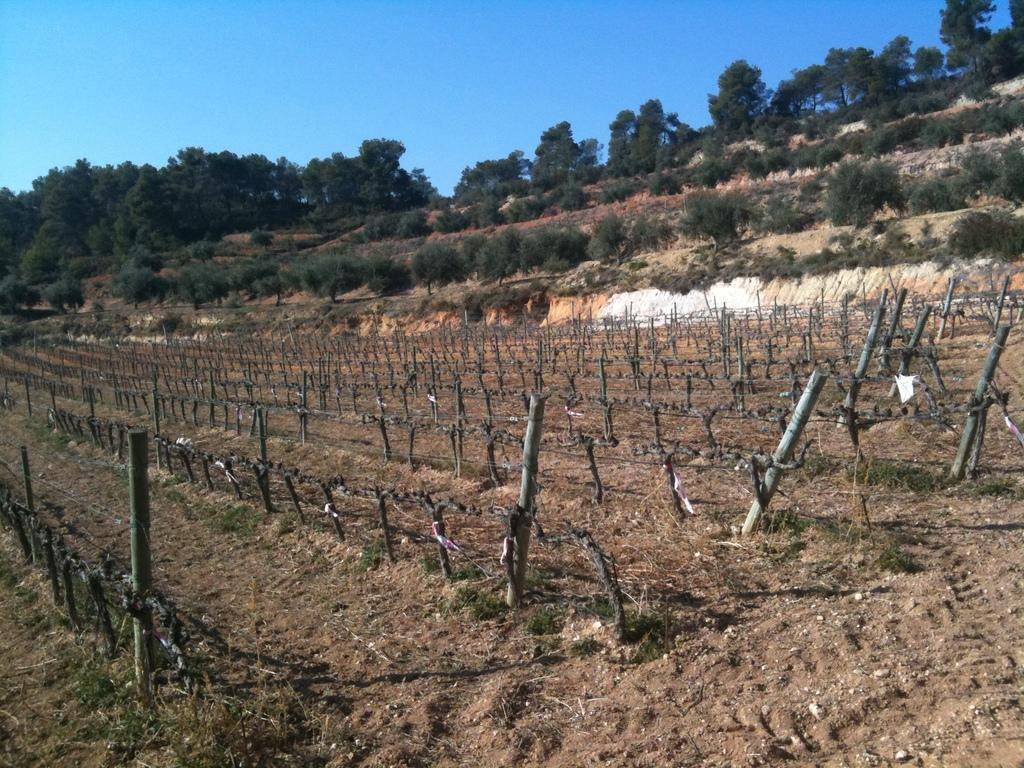What type of structure can be seen in the image? There is fencing in the image. What can be seen in the background of the image? There are trees in the background of the image. What is the color of the trees? The trees are green in color. What is the color of the sky in the image? The sky is blue in color. How many gold coins can be seen on the ground in the image? There are no gold coins present in the image. Can you describe the robin's nest in the image? There is no robin or nest present in the image. 